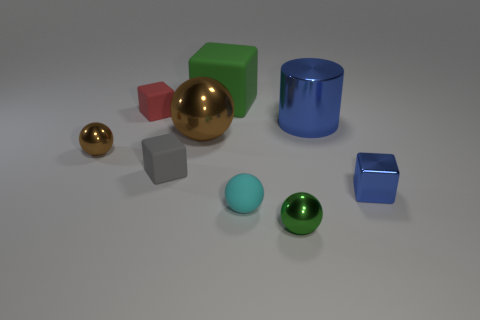Subtract 1 balls. How many balls are left? 3 Subtract all purple spheres. Subtract all red cylinders. How many spheres are left? 4 Add 1 tiny yellow metal spheres. How many objects exist? 10 Subtract all spheres. How many objects are left? 5 Add 7 big cubes. How many big cubes are left? 8 Add 5 brown spheres. How many brown spheres exist? 7 Subtract 0 yellow cubes. How many objects are left? 9 Subtract all large metal cylinders. Subtract all gray rubber objects. How many objects are left? 7 